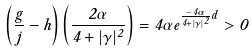<formula> <loc_0><loc_0><loc_500><loc_500>\left ( \frac { g } { j } - h \right ) \left ( \frac { 2 \alpha } { 4 + | \gamma | ^ { 2 } } \right ) = 4 \alpha e ^ { \frac { - 4 \alpha } { 4 + | \gamma | ^ { 2 } } d } > 0</formula> 